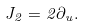<formula> <loc_0><loc_0><loc_500><loc_500>J _ { 2 } = 2 \partial _ { u } .</formula> 